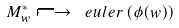Convert formula to latex. <formula><loc_0><loc_0><loc_500><loc_500>M _ { w } ^ { * } \longmapsto \ e u l e r \left ( \phi ( w ) \right )</formula> 